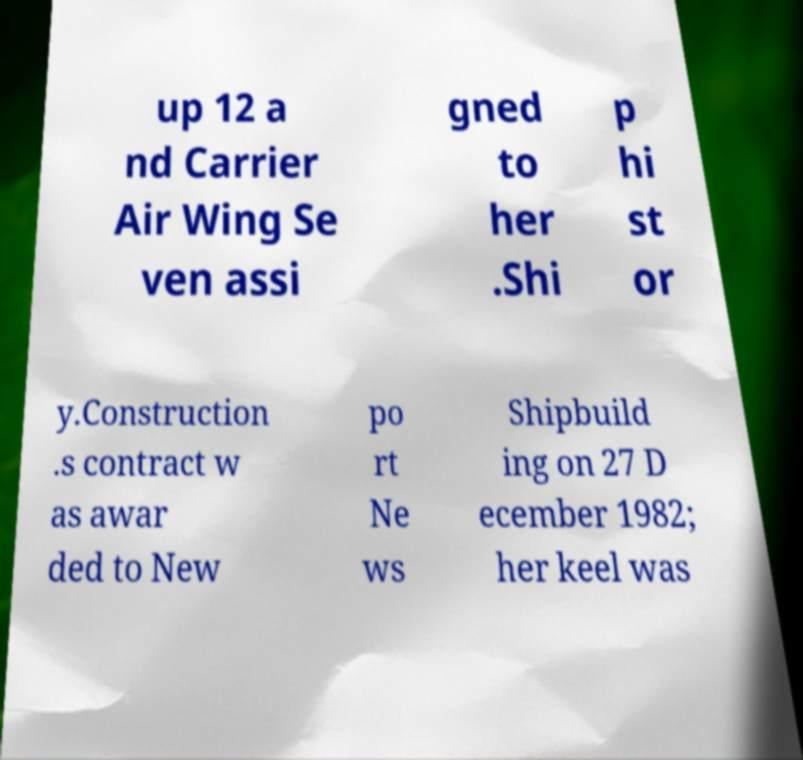There's text embedded in this image that I need extracted. Can you transcribe it verbatim? up 12 a nd Carrier Air Wing Se ven assi gned to her .Shi p hi st or y.Construction .s contract w as awar ded to New po rt Ne ws Shipbuild ing on 27 D ecember 1982; her keel was 